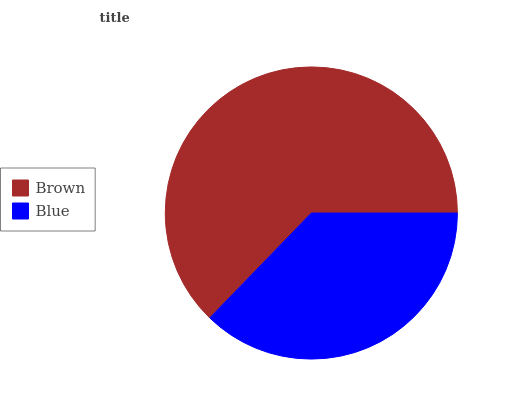Is Blue the minimum?
Answer yes or no. Yes. Is Brown the maximum?
Answer yes or no. Yes. Is Blue the maximum?
Answer yes or no. No. Is Brown greater than Blue?
Answer yes or no. Yes. Is Blue less than Brown?
Answer yes or no. Yes. Is Blue greater than Brown?
Answer yes or no. No. Is Brown less than Blue?
Answer yes or no. No. Is Brown the high median?
Answer yes or no. Yes. Is Blue the low median?
Answer yes or no. Yes. Is Blue the high median?
Answer yes or no. No. Is Brown the low median?
Answer yes or no. No. 